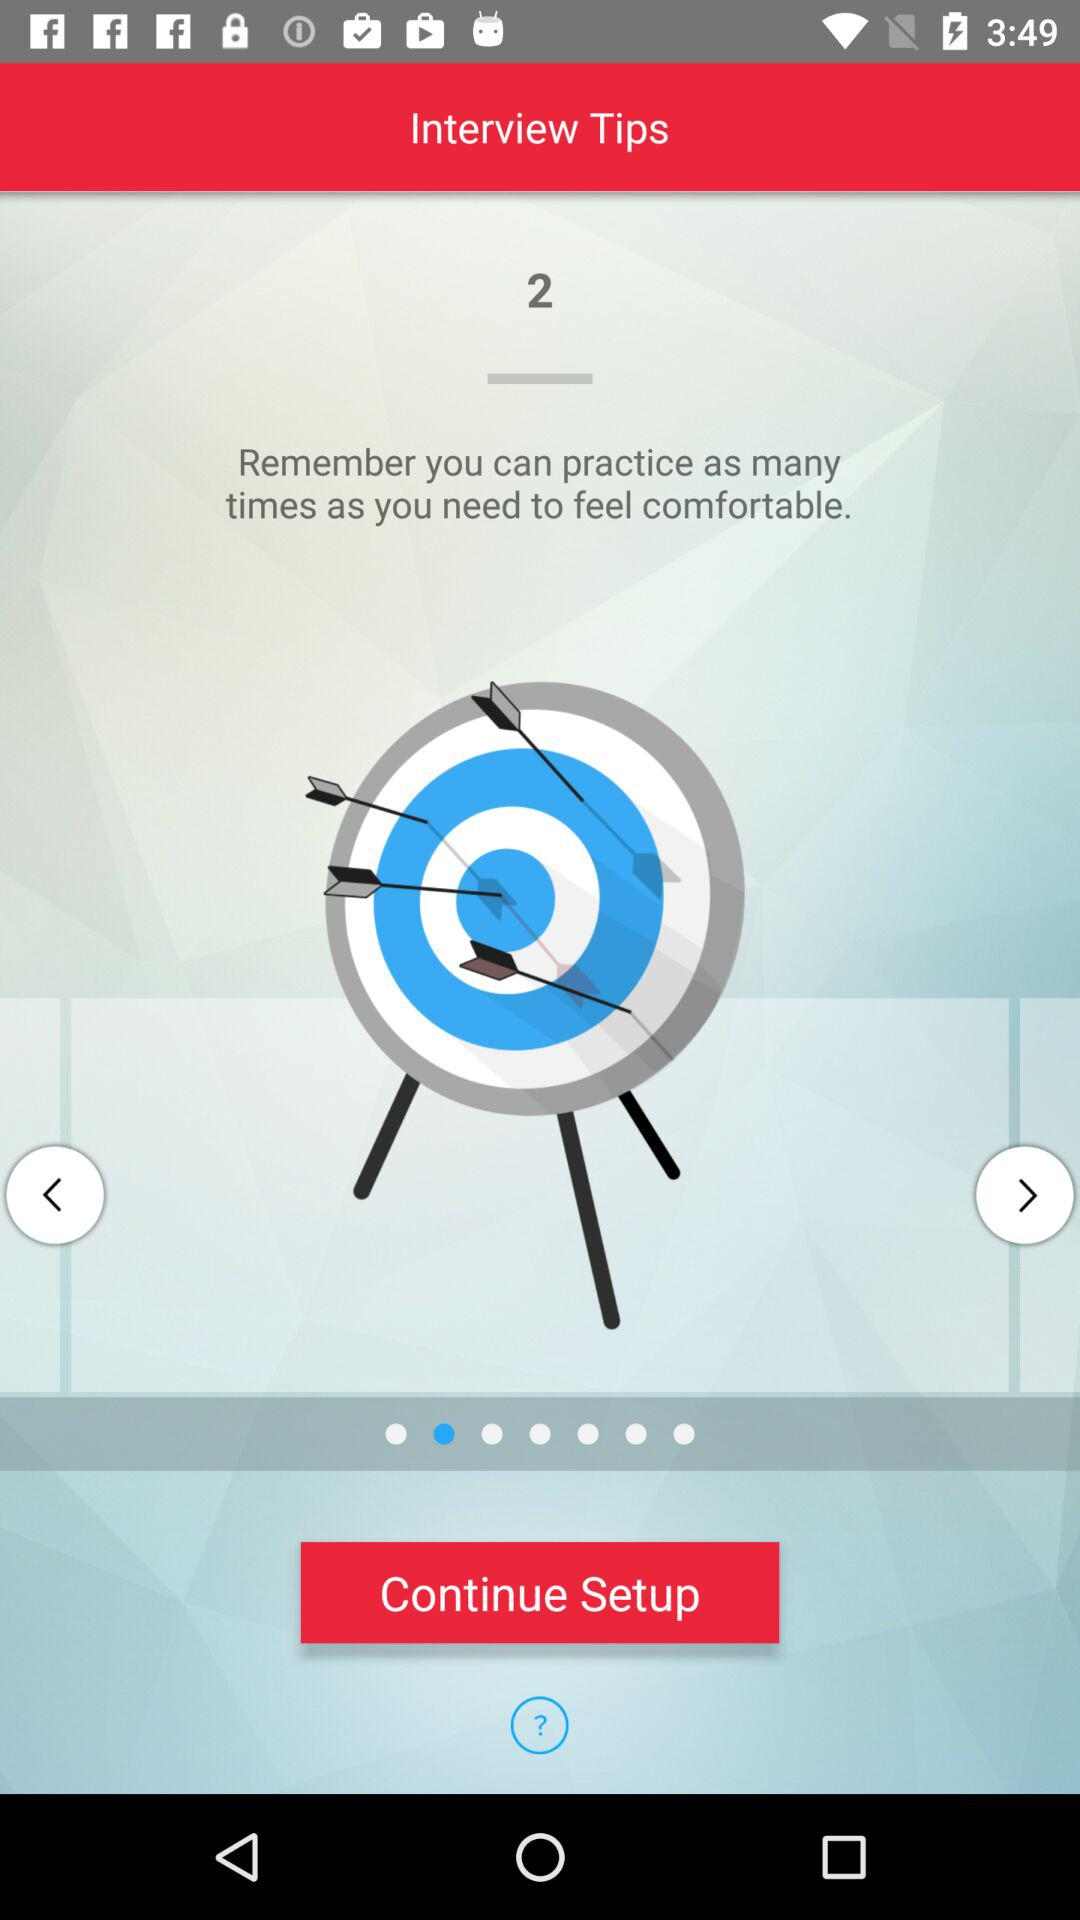How many times can we practice? You can practice many times. 